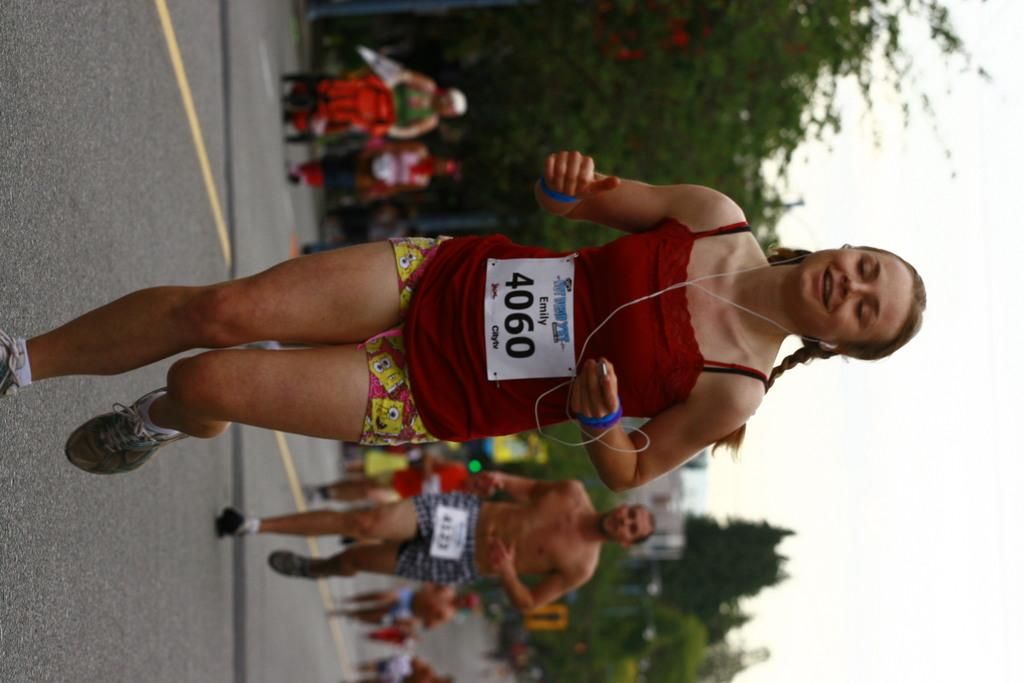<image>
Give a short and clear explanation of the subsequent image. A runner named Emily and number 4060 runs on the street, 